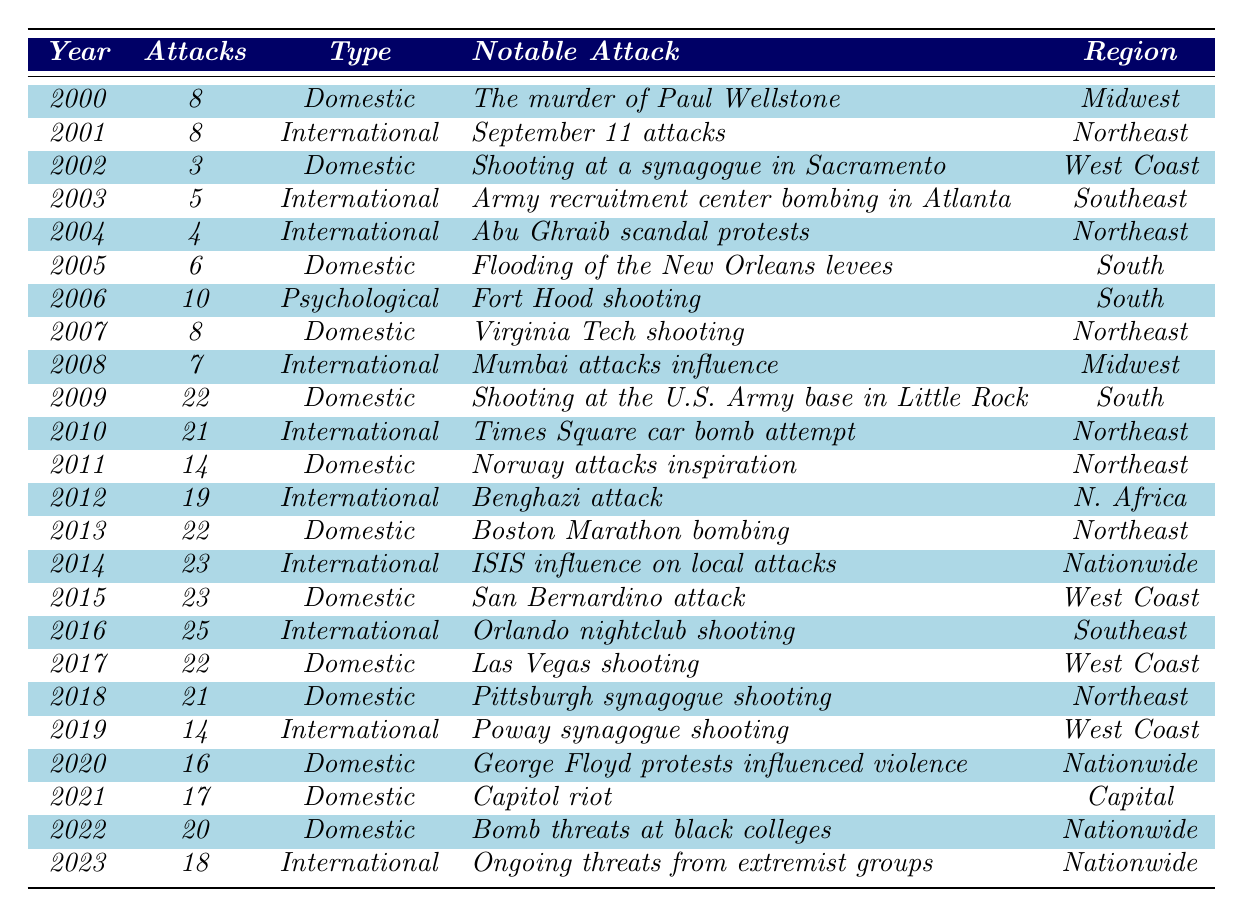What year had the highest number of attacks? By examining the 'Attacks' column, the year with the highest value is 2016, with 25 attacks.
Answer: 2016 How many total terrorist attacks occurred from 2000 to 2023? To find the total, we add all the values in the 'Attacks' column: 8 + 8 + 3 + 5 + 4 + 6 + 10 + 8 + 7 + 22 + 21 + 14 + 19 + 22 + 23 + 23 + 25 + 22 + 21 + 14 + 16 + 17 + 20 + 18 =  396.
Answer: 396 In which year did the notable attack 'Orlando nightclub shooting' occur? The notable attack 'Orlando nightclub shooting' is listed in the year 2016.
Answer: 2016 Was there a year with no attacks recorded? By reviewing the values in the 'Attacks' column, all years listed have at least one attack recorded.
Answer: No Which primary type of terrorism had the most attacks on average from 2000 to 2023? First, we categorize the number of attacks by each primary type and then calculate the average: Domestic Extremism (8+3+6+8+22+14+22+23+21+16+17+20+18 =  195, total years = 13) -> average is 15; International Terrorism (8+5+4+21+19+23+25+14+14+18 =  123, total years = 10) -> average is 12.3; Psychological Warfare (10, 1 year) -> average is 10. Overall, Domestic Extremism has the highest average of 15 attacks per year.
Answer: Domestic Extremism In how many years did more than 20 attacks occur? By scanning the table, the years with more than 20 attacks are 2009 (22), 2010 (21), 2013 (22), 2014 (23), 2015 (23), 2016 (25), and 2017 (22). There are 7 years in total.
Answer: 7 Which region had the most attacks in the year with the notable attack 'Boston Marathon bombing'? Looking at the year 2013 in the table, it shows 22 attacks occurring in the 'Northeast' region for the notable attack 'Boston Marathon bombing'.
Answer: Northeast Compare the number of terrorist attacks between 2001 and 2003. Which year had a higher count and by how much? In 2001, there were 8 attacks, whereas in 2003, there were 5 attacks. The difference is 8 - 5 = 3, meaning 2001 had 3 more attacks than 2003.
Answer: 2001 had 3 more attacks than 2003 During which period did the U.S. experience the highest number of attacks categorized as 'International Terrorism'? By reviewing the 'International Terrorism' category, 2016 has the highest number with 25 attacks.
Answer: 2016 What notable attack occurred in the year with the second least number of attacks? The year with the second least number of attacks is 2002 with 3 attacks, the notable attack listed is the 'Shooting at a synagogue in Sacramento'.
Answer: Shooting at a synagogue in Sacramento Was there an increase in domestic extremist attacks from 2020 to 2021? Comparing 2020 (16 attacks) and 2021 (17 attacks), there was an increase of 1 attack in the 'Domestic Extremism' category.
Answer: Yes, there was an increase of 1 attack 